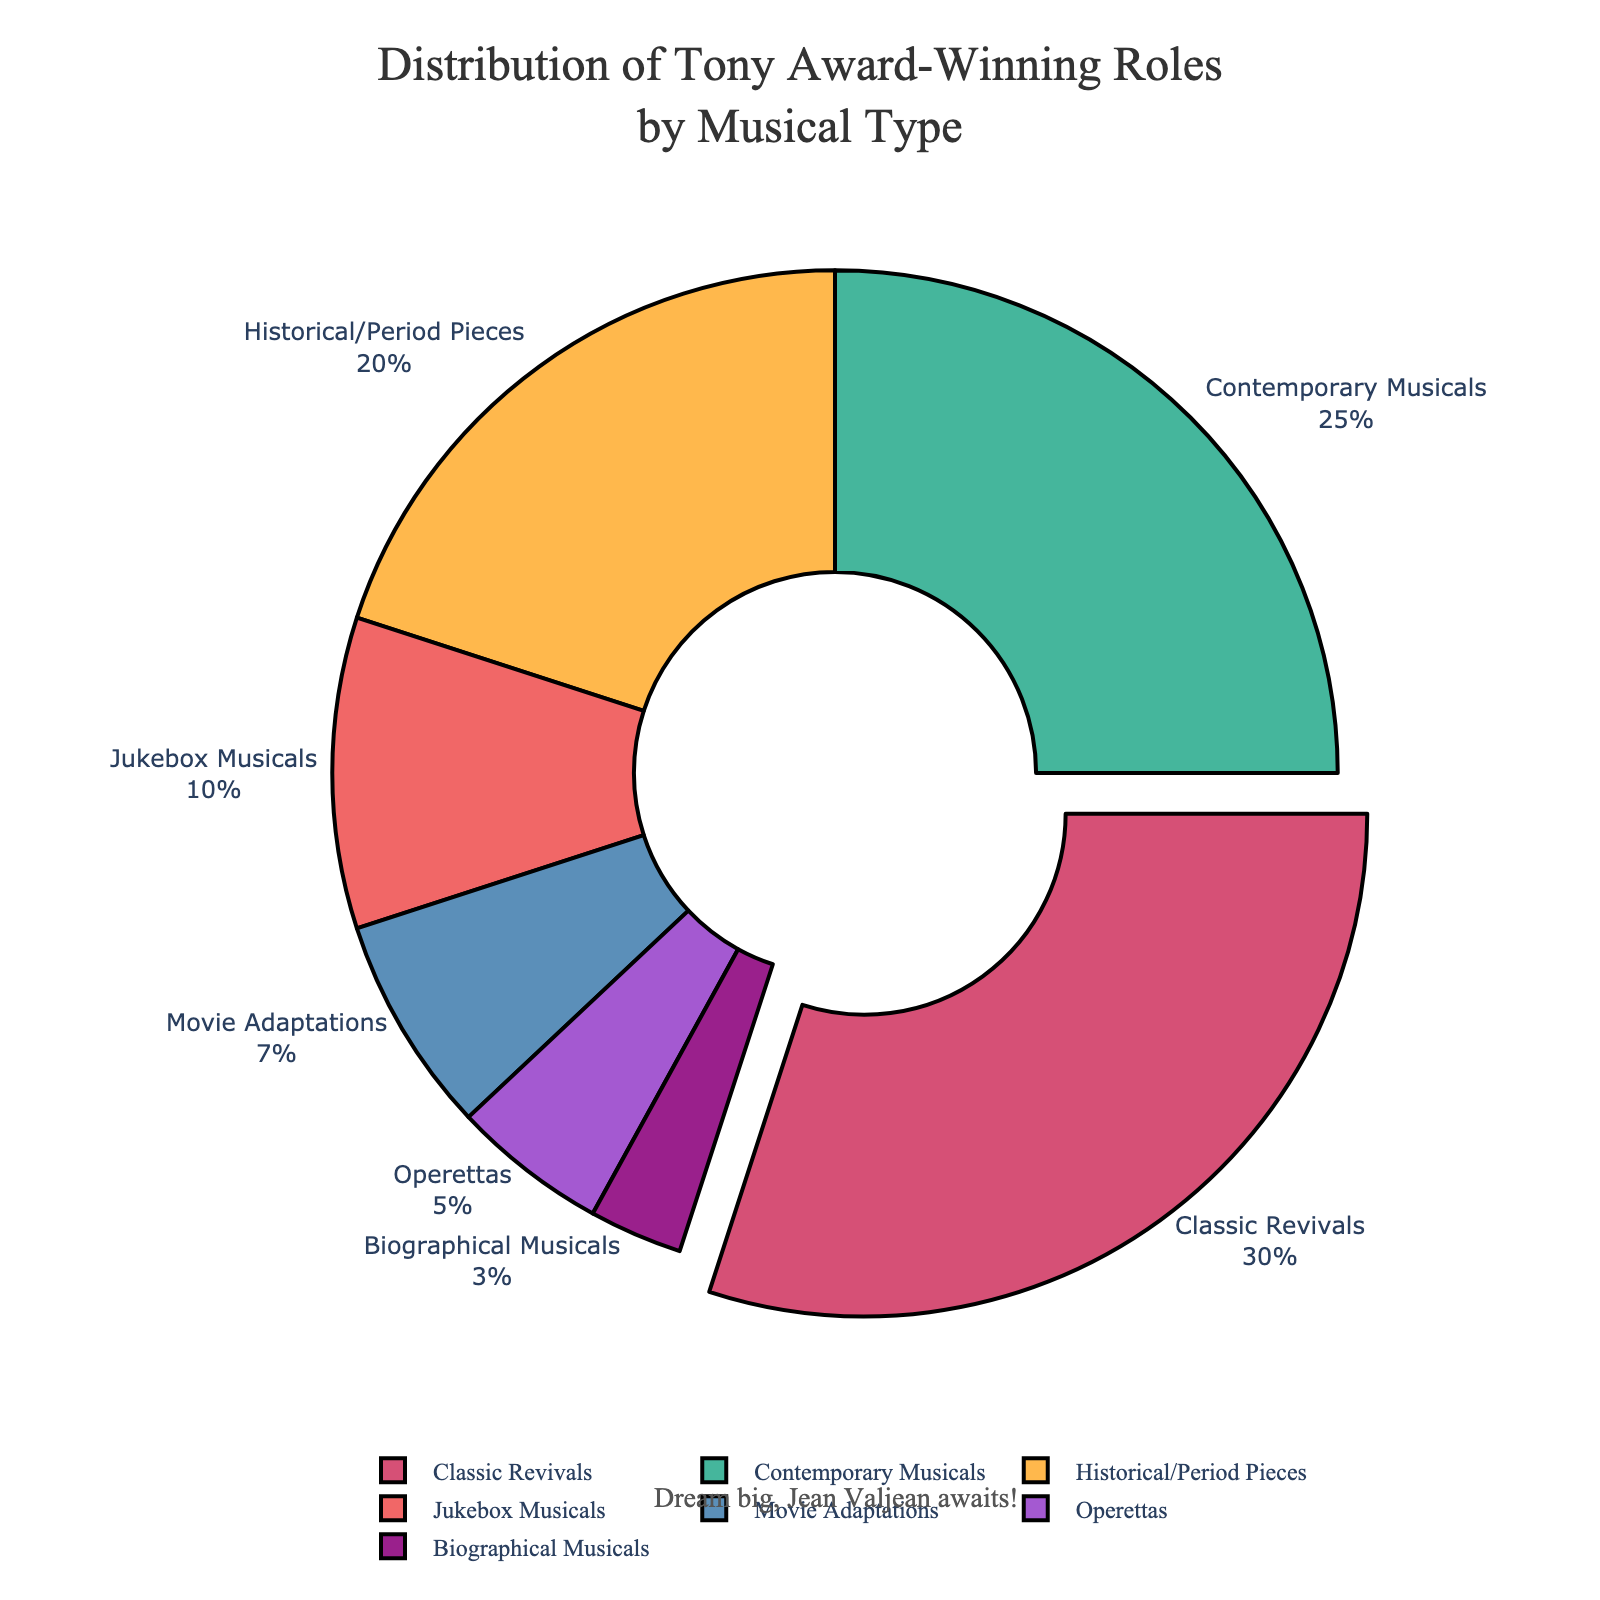Which musical type has the largest percentage of roles played by Tony Award-winning actors? The segment with the largest percentage is pulled out from the rest of the pie chart, and the text displayed shows it as Classic Revivals with 30%.
Answer: Classic Revivals What is the total percentage of roles played in both Contemporary Musicals and Historical/Period Pieces? Add the percentages of Contemporary Musicals (25%) and Historical/Period Pieces (20%). 25% + 20% = 45%
Answer: 45% How does the percentage of roles in Biographical Musicals compare to that in Jukebox Musicals? The pie chart shows Biographical Musicals at 3% and Jukebox Musicals at 10%. Thus, Jukebox Musicals have a higher percentage of roles.
Answer: Jukebox Musicals have more roles What percentage difference is there between Classic Revivals and Movie Adaptations? Subtract the percentage of Movie Adaptations (7%) from Classic Revivals (30%). 30% - 7% = 23%
Answer: 23% Which musical type occupies the smallest segment in the pie chart? The segment labeled 3% has the smallest percentage, which corresponds to Biographical Musicals.
Answer: Biographical Musicals What is the combined percentage of roles played in Operettas, Movie Adaptations, and Biographical Musicals? Sum the percentages of Operettas (5%), Movie Adaptations (7%), and Biographical Musicals (3%). 5% + 7% + 3% = 15%
Answer: 15% What visual feature helps you identify the musical type with the highest percentage at a glance? The largest segment is pulled outwards from the pie chart, and the text showing 30% aids in identifying it as Classic Revivals.
Answer: Pulled-out segment Compare the percentage of roles played in Contemporary Musicals to the total percentage of roles in Jukebox Musicals and Operettas combined. Jukebox Musicals (10%) and Operettas (5%) together make 15%, which is less than Contemporary Musicals' 25%.
Answer: Contemporary Musicals have a higher percentage By how much is the percentage of roles in Historical/Period Pieces greater than that in Movie Adaptations? Subtract the percentage of Movie Adaptations (7%) from Historical/Period Pieces (20%). 20% - 7% = 13%
Answer: 13% What does the annotation "Dream big, Jean Valjean awaits!" imply in the context of the pie chart? It serves as an inspiring message, connecting the pie chart's data to an aspirational note for Broadway performers, especially those eyeing significant roles like Jean Valjean.
Answer: Inspirational message 